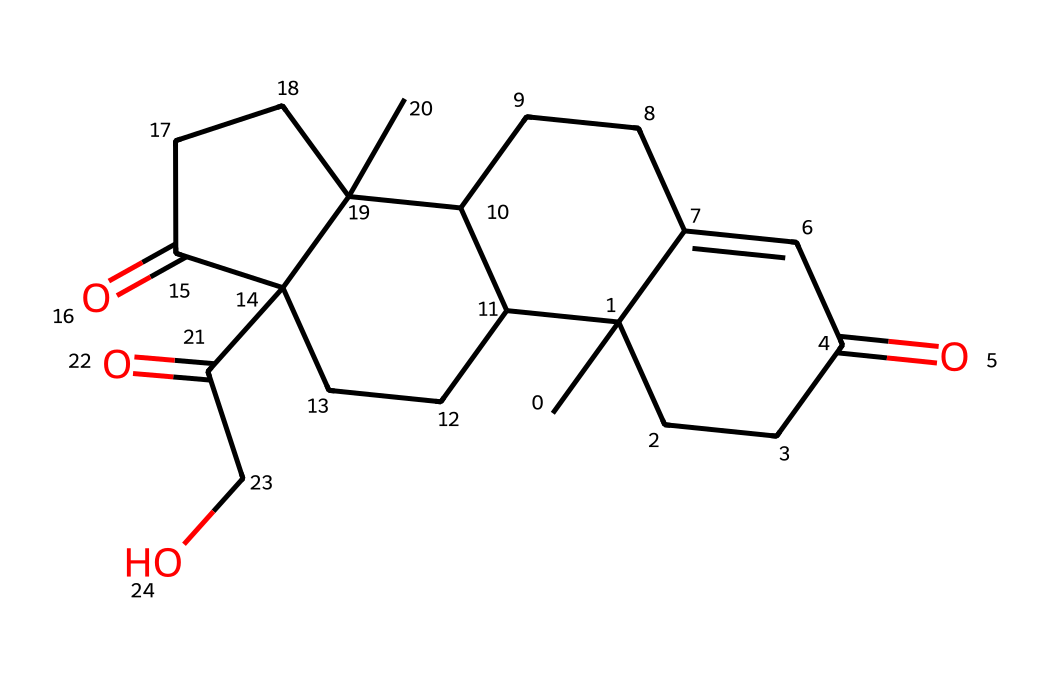How many carbon atoms are in cortisol? In the SMILES representation, each "C" represents a carbon atom. By counting the number of "C" letters in the SMILES string, we find there are 21 carbon atoms.
Answer: 21 What functional groups are present in cortisol? The chemical structure of cortisol contains ketone groups (C=O). In the SMILES, they are represented by the "(=O)" portions. There are three ketone groups identified in the structure.
Answer: ketone groups Is cortisol a sterol, steroid, or neither? The structure contains four fused carbon rings characteristic of steroids, which can be identified by the arrangement of carbon atoms forming a tetracyclic structure. Therefore, cortisol is categorized as a steroid.
Answer: steroid What is the molecular formula of cortisol? By interpreting the SMILES and counting the number of each type of atom, we find that cortisol consists of 21 carbon atoms, 30 hydrogen atoms, and 5 oxygen atoms, leading to a molecular formula of C21H30O5.
Answer: C21H30O5 How many oxygen atoms are in cortisol? Oxygen atoms are represented by "O" in the SMILES. By counting the number of "O" characters, we can determine there are 5 oxygen atoms in the structure.
Answer: 5 What distinguishes cortisol’s structure compared to other hormones? Cortisol has a unique arrangement of carbon rings with specific functional groups, like the ketones, that differentiate it from other hormones which might have different functional groups or carbon arrangements.
Answer: unique carbon arrangement Which part of cortisol contributes to its signaling function in the body? The hydroxyl group (–OH) contributes to hormonal signaling by allowing interactions with receptors, thereby facilitating its role as a stress hormone. This feature can be inferred from its chemical structure.
Answer: hydroxyl group 